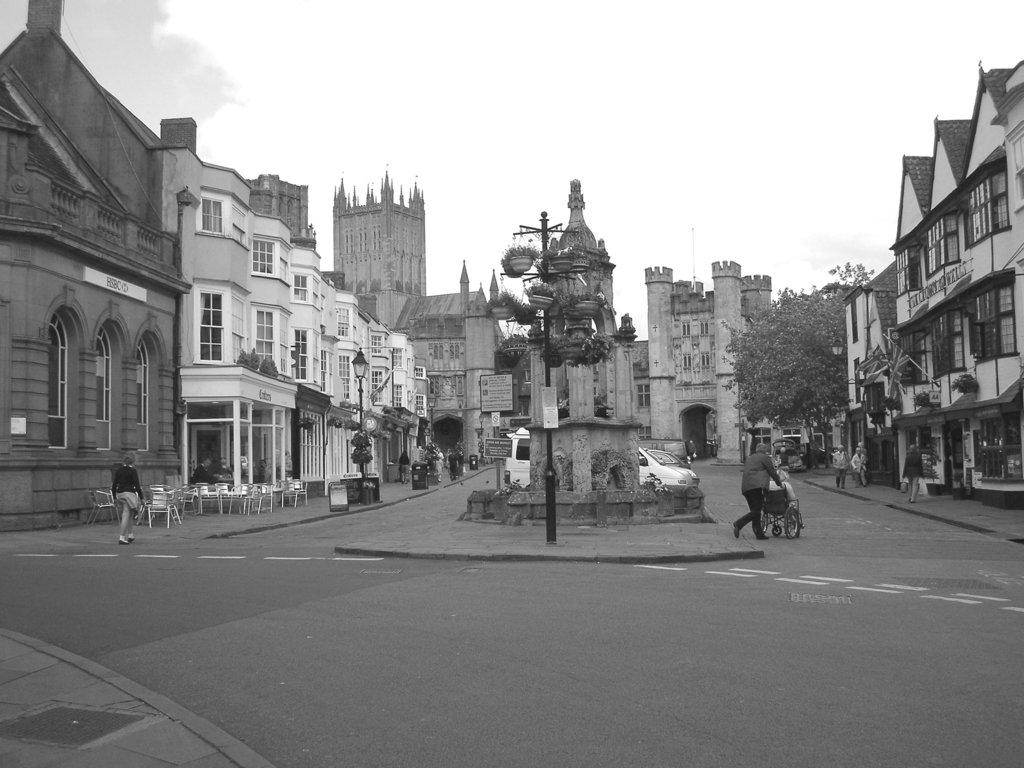What type of structures can be seen in the image? There are buildings in the image. What are the tall, thin objects in the image? There are poles in the image. Who or what is present in the image besides the buildings and poles? There are people and chairs in the image. Can you describe any other objects in the image? There are other unspecified objects in the image. How much money is being exchanged between the people at the party in the image? There is no party or money exchange present in the image. What type of rose is being held by the person in the image? There is no person or rose present in the image. 